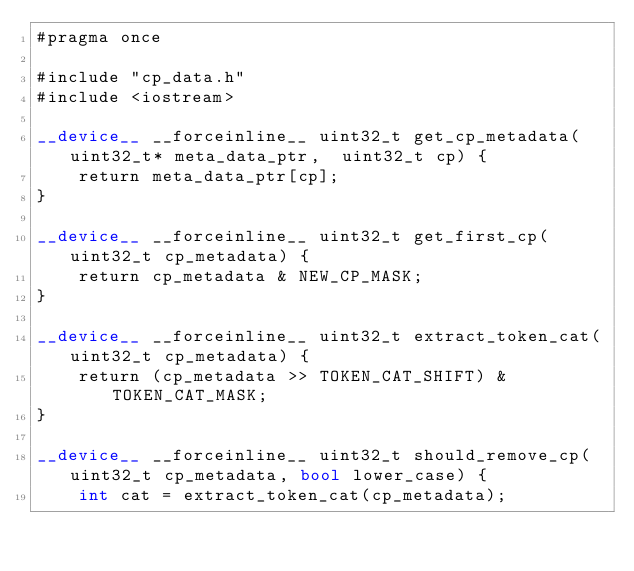Convert code to text. <code><loc_0><loc_0><loc_500><loc_500><_Cuda_>#pragma once

#include "cp_data.h"
#include <iostream>

__device__ __forceinline__ uint32_t get_cp_metadata(uint32_t* meta_data_ptr,  uint32_t cp) {
    return meta_data_ptr[cp];
}

__device__ __forceinline__ uint32_t get_first_cp(uint32_t cp_metadata) {
    return cp_metadata & NEW_CP_MASK;        
}

__device__ __forceinline__ uint32_t extract_token_cat(uint32_t cp_metadata) {
    return (cp_metadata >> TOKEN_CAT_SHIFT) & TOKEN_CAT_MASK;
}

__device__ __forceinline__ uint32_t should_remove_cp(uint32_t cp_metadata, bool lower_case) {
    int cat = extract_token_cat(cp_metadata);</code> 